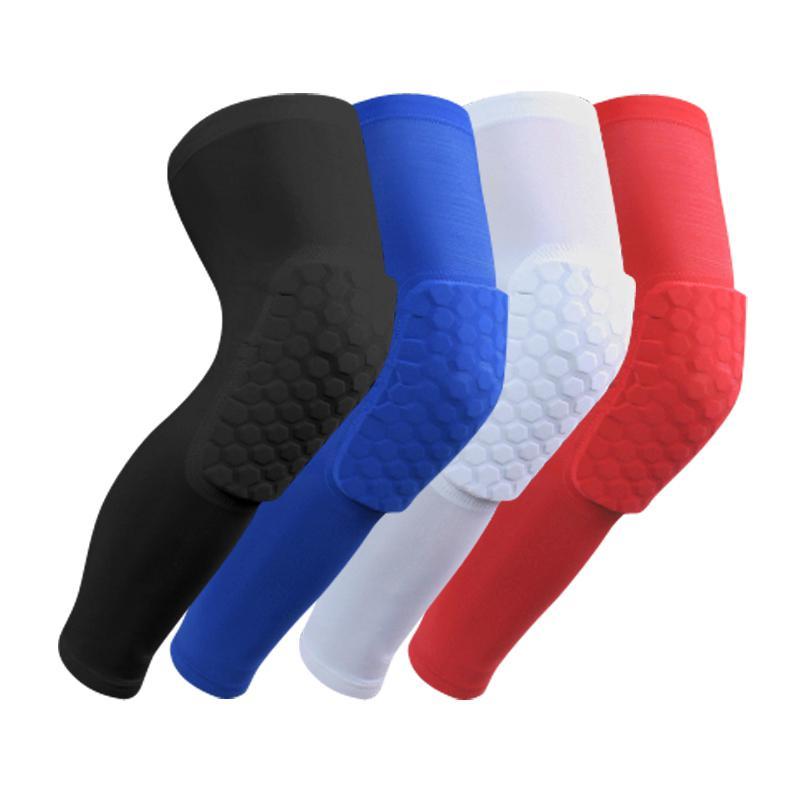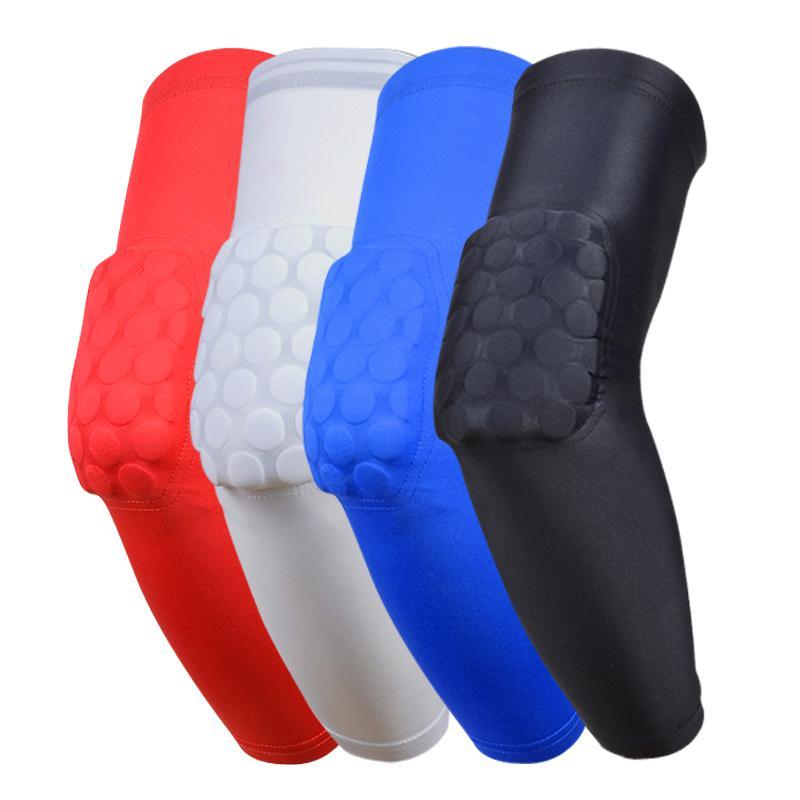The first image is the image on the left, the second image is the image on the right. For the images displayed, is the sentence "One of the images shows exactly one knee pad." factually correct? Answer yes or no. No. The first image is the image on the left, the second image is the image on the right. Given the left and right images, does the statement "There is a white knee pad next to a red knee pad" hold true? Answer yes or no. Yes. 